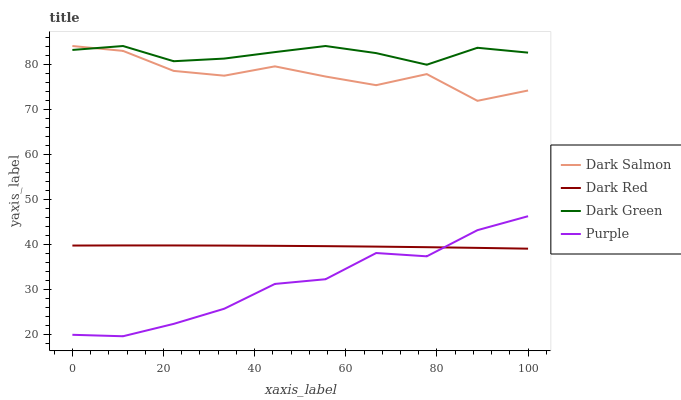Does Purple have the minimum area under the curve?
Answer yes or no. Yes. Does Dark Green have the maximum area under the curve?
Answer yes or no. Yes. Does Dark Red have the minimum area under the curve?
Answer yes or no. No. Does Dark Red have the maximum area under the curve?
Answer yes or no. No. Is Dark Red the smoothest?
Answer yes or no. Yes. Is Dark Salmon the roughest?
Answer yes or no. Yes. Is Dark Salmon the smoothest?
Answer yes or no. No. Is Dark Red the roughest?
Answer yes or no. No. Does Purple have the lowest value?
Answer yes or no. Yes. Does Dark Red have the lowest value?
Answer yes or no. No. Does Dark Green have the highest value?
Answer yes or no. Yes. Does Dark Red have the highest value?
Answer yes or no. No. Is Purple less than Dark Green?
Answer yes or no. Yes. Is Dark Salmon greater than Dark Red?
Answer yes or no. Yes. Does Dark Green intersect Dark Salmon?
Answer yes or no. Yes. Is Dark Green less than Dark Salmon?
Answer yes or no. No. Is Dark Green greater than Dark Salmon?
Answer yes or no. No. Does Purple intersect Dark Green?
Answer yes or no. No. 